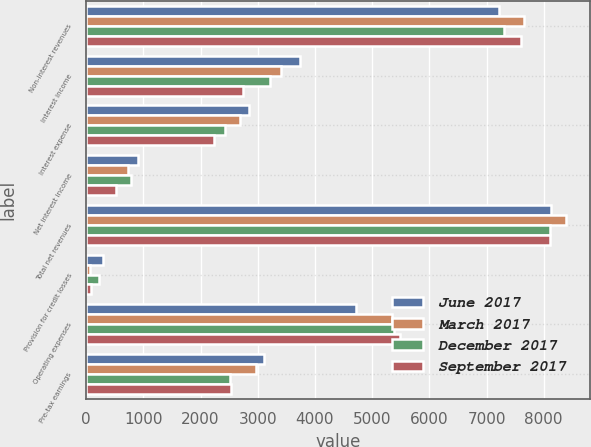<chart> <loc_0><loc_0><loc_500><loc_500><stacked_bar_chart><ecel><fcel>Non-interest revenues<fcel>Interest income<fcel>Interest expense<fcel>Net interest income<fcel>Total net revenues<fcel>Provision for credit losses<fcel>Operating expenses<fcel>Pre-tax earnings<nl><fcel>June 2017<fcel>7226<fcel>3736<fcel>2838<fcel>898<fcel>8124<fcel>290<fcel>4726<fcel>3108<nl><fcel>March 2017<fcel>7660<fcel>3411<fcel>2681<fcel>730<fcel>8390<fcel>64<fcel>5350<fcel>2976<nl><fcel>December 2017<fcel>7314<fcel>3220<fcel>2432<fcel>788<fcel>8102<fcel>215<fcel>5378<fcel>2509<nl><fcel>September 2017<fcel>7598<fcel>2746<fcel>2230<fcel>516<fcel>8114<fcel>88<fcel>5487<fcel>2539<nl></chart> 